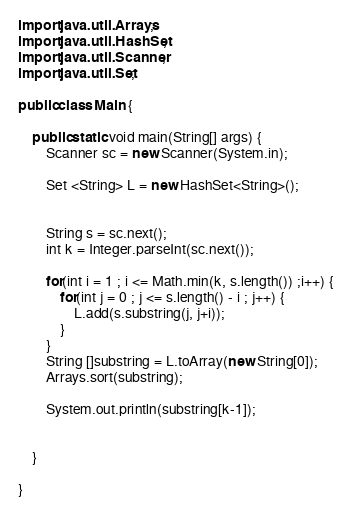<code> <loc_0><loc_0><loc_500><loc_500><_Java_>
import java.util.Arrays;
import java.util.HashSet;
import java.util.Scanner;
import java.util.Set;

public class Main {

	public static void main(String[] args) {
		Scanner sc = new Scanner(System.in);
		
		Set <String> L = new HashSet<String>();
		
		
		String s = sc.next();
		int k = Integer.parseInt(sc.next());
		
		for(int i = 1 ; i <= Math.min(k, s.length()) ;i++) {
			for(int j = 0 ; j <= s.length() - i ; j++) {
				L.add(s.substring(j, j+i));
			}
		}
		String []substring = L.toArray(new String[0]);
		Arrays.sort(substring);
		
		System.out.println(substring[k-1]);
		

	}

}
</code> 